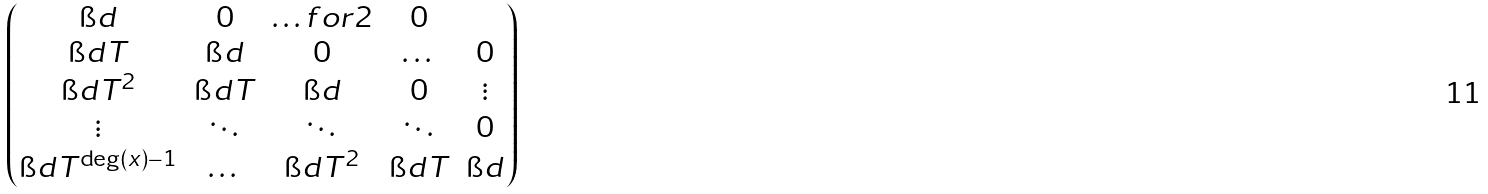<formula> <loc_0><loc_0><loc_500><loc_500>\begin{pmatrix} \i d & 0 & \hdots f o r { 2 } & 0 \\ \i d T & \i d & 0 & \dots & 0 \\ \i d T ^ { 2 } & \i d T & \i d & 0 & \vdots \\ \vdots & \ddots & \ddots & \ddots & 0 \\ \i d T ^ { \deg ( x ) - 1 } & \dots & \i d T ^ { 2 } & \i d T & \i d \end{pmatrix}</formula> 